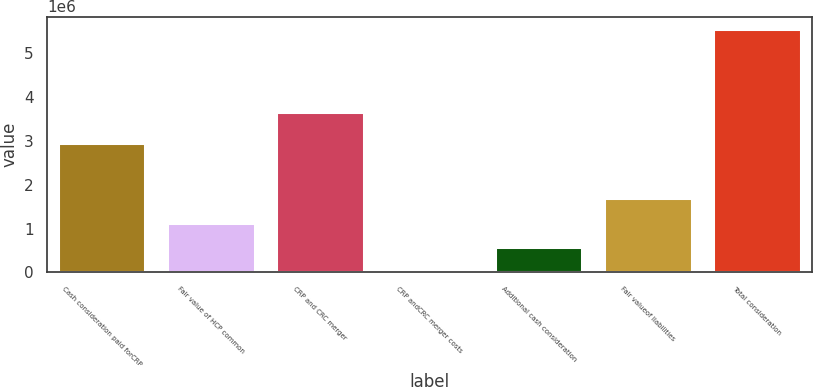<chart> <loc_0><loc_0><loc_500><loc_500><bar_chart><fcel>Cash consideration paid forCRP<fcel>Fair value of HCP common<fcel>CRP and CRC merger<fcel>CRP andCRC merger costs<fcel>Additional cash consideration<fcel>Fair valueof liabilities<fcel>Total consideration<nl><fcel>2.94873e+06<fcel>1.13499e+06<fcel>3.66911e+06<fcel>27983<fcel>581486<fcel>1.68849e+06<fcel>5.56301e+06<nl></chart> 